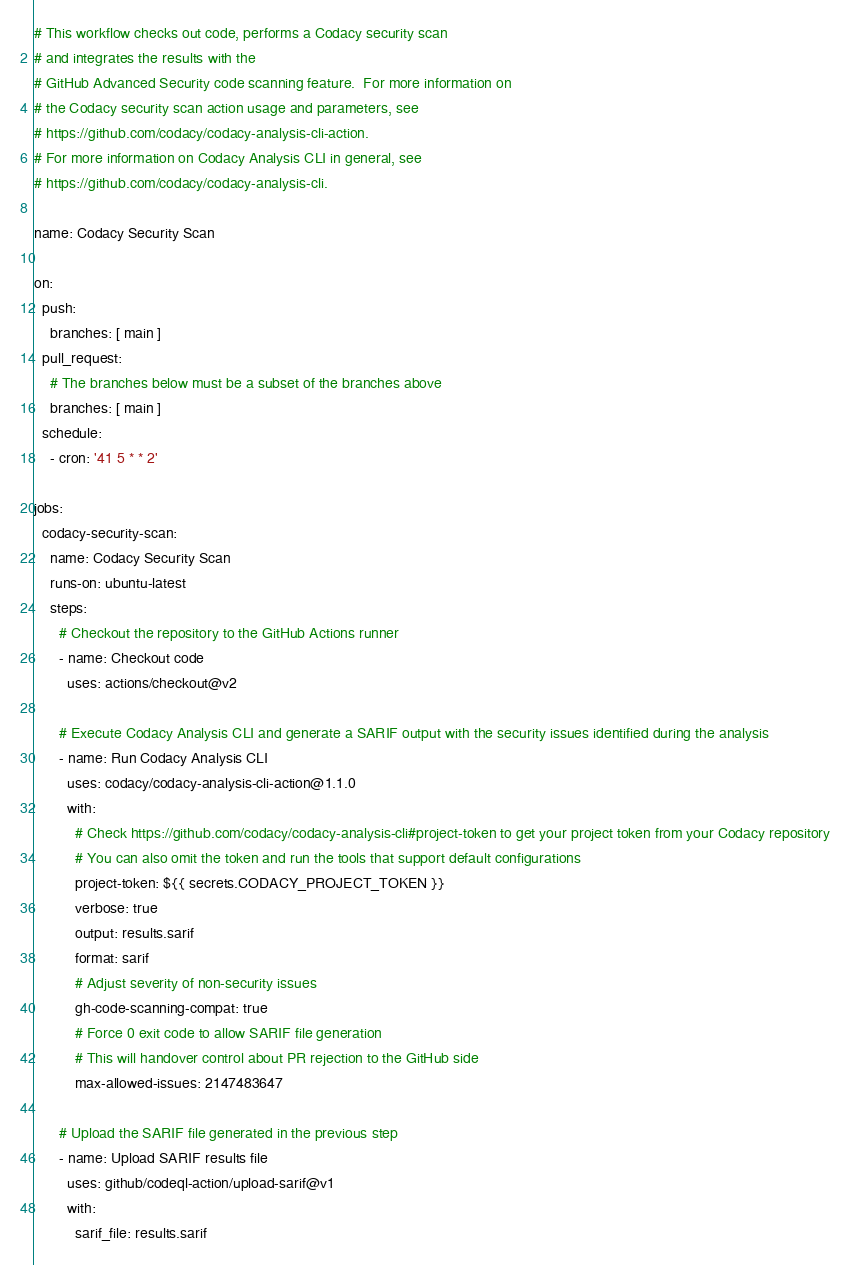<code> <loc_0><loc_0><loc_500><loc_500><_YAML_># This workflow checks out code, performs a Codacy security scan
# and integrates the results with the
# GitHub Advanced Security code scanning feature.  For more information on
# the Codacy security scan action usage and parameters, see
# https://github.com/codacy/codacy-analysis-cli-action.
# For more information on Codacy Analysis CLI in general, see
# https://github.com/codacy/codacy-analysis-cli.

name: Codacy Security Scan

on:
  push:
    branches: [ main ]
  pull_request:
    # The branches below must be a subset of the branches above
    branches: [ main ]
  schedule:
    - cron: '41 5 * * 2'

jobs:
  codacy-security-scan:
    name: Codacy Security Scan
    runs-on: ubuntu-latest
    steps:
      # Checkout the repository to the GitHub Actions runner
      - name: Checkout code
        uses: actions/checkout@v2

      # Execute Codacy Analysis CLI and generate a SARIF output with the security issues identified during the analysis
      - name: Run Codacy Analysis CLI
        uses: codacy/codacy-analysis-cli-action@1.1.0
        with:
          # Check https://github.com/codacy/codacy-analysis-cli#project-token to get your project token from your Codacy repository
          # You can also omit the token and run the tools that support default configurations
          project-token: ${{ secrets.CODACY_PROJECT_TOKEN }}
          verbose: true
          output: results.sarif
          format: sarif
          # Adjust severity of non-security issues
          gh-code-scanning-compat: true
          # Force 0 exit code to allow SARIF file generation
          # This will handover control about PR rejection to the GitHub side
          max-allowed-issues: 2147483647

      # Upload the SARIF file generated in the previous step
      - name: Upload SARIF results file
        uses: github/codeql-action/upload-sarif@v1
        with:
          sarif_file: results.sarif
</code> 